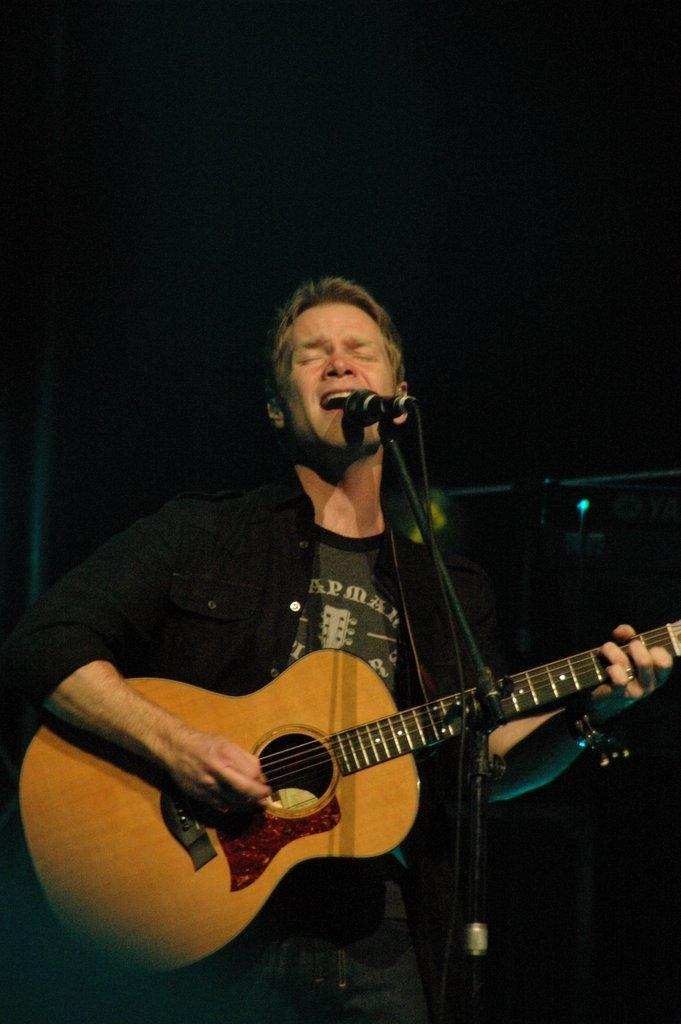What is the man in the image doing? The man is playing a guitar and singing on a microphone. What is the man wearing in the image? The man is wearing a black shirt and black jeans. What can be seen in the background of the image? The background of the image is dark. How much sugar is in the man's hand in the image? There is no sugar present in the image, and the man's hand is not shown. What type of land can be seen in the background of the image? The background of the image is dark, and no land is visible. 